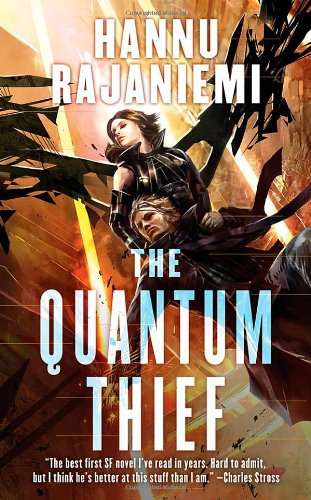Is this a fitness book? No, this book delves into science fiction and fantasy, far removed from the themes typically explored in fitness literature. 